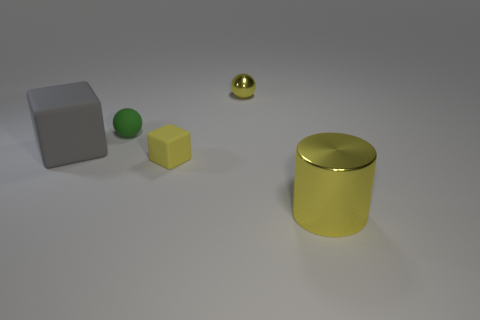There is a green matte object; are there any small green rubber objects in front of it?
Give a very brief answer. No. There is a big metallic object; what shape is it?
Give a very brief answer. Cylinder. What number of objects are small yellow objects that are in front of the small green rubber object or blue rubber blocks?
Provide a short and direct response. 1. What number of other things are the same color as the big rubber block?
Ensure brevity in your answer.  0. Is the color of the tiny block the same as the thing that is in front of the yellow block?
Give a very brief answer. Yes. There is a large matte thing that is the same shape as the tiny yellow rubber object; what is its color?
Give a very brief answer. Gray. Does the tiny yellow block have the same material as the tiny sphere that is left of the tiny yellow shiny sphere?
Make the answer very short. Yes. What color is the cylinder?
Provide a short and direct response. Yellow. The rubber object that is on the left side of the green sphere in front of the yellow object that is behind the gray cube is what color?
Your answer should be compact. Gray. Does the gray object have the same shape as the metal thing that is behind the large yellow cylinder?
Provide a short and direct response. No. 